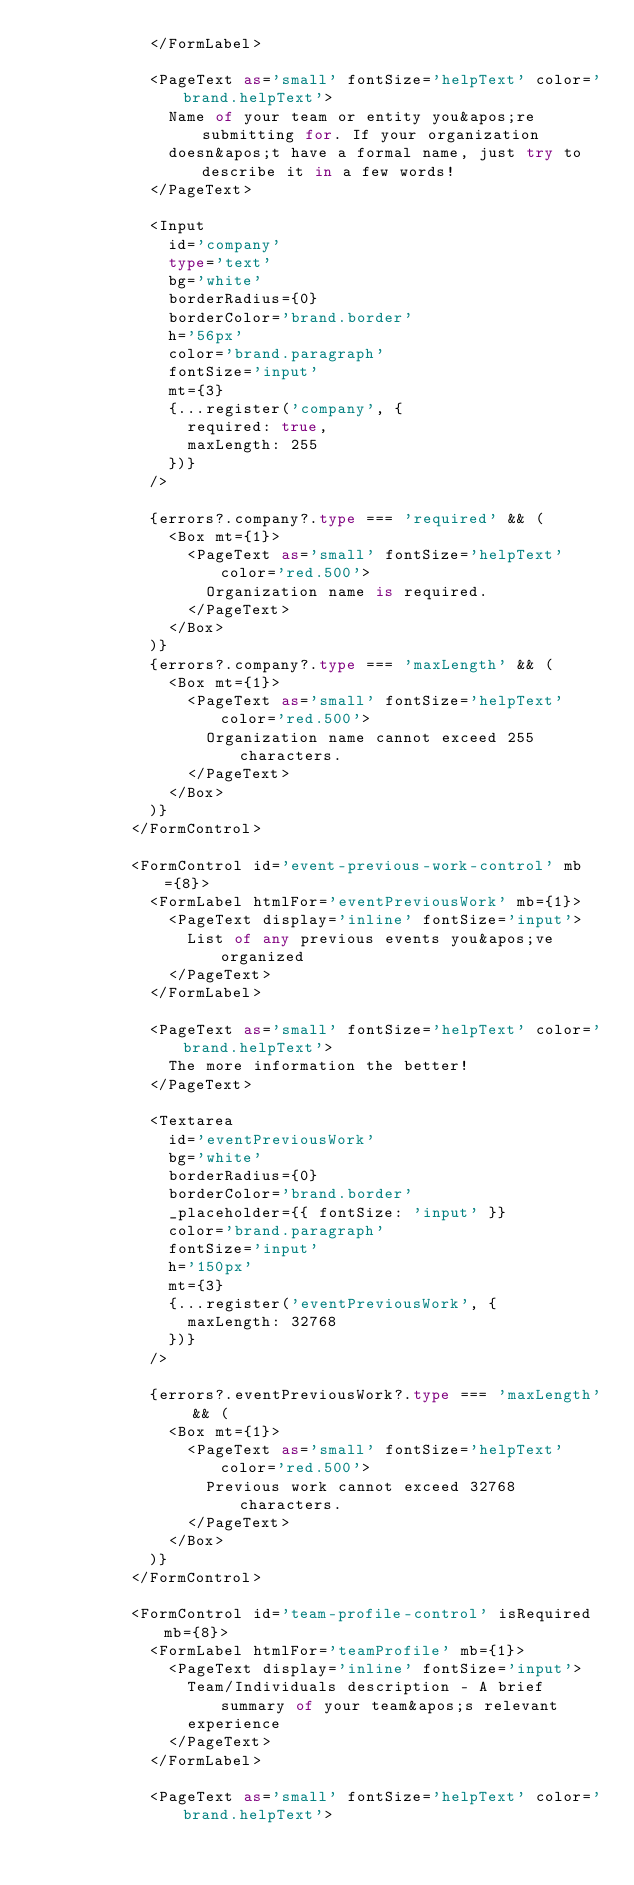Convert code to text. <code><loc_0><loc_0><loc_500><loc_500><_TypeScript_>            </FormLabel>

            <PageText as='small' fontSize='helpText' color='brand.helpText'>
              Name of your team or entity you&apos;re submitting for. If your organization
              doesn&apos;t have a formal name, just try to describe it in a few words!
            </PageText>

            <Input
              id='company'
              type='text'
              bg='white'
              borderRadius={0}
              borderColor='brand.border'
              h='56px'
              color='brand.paragraph'
              fontSize='input'
              mt={3}
              {...register('company', {
                required: true,
                maxLength: 255
              })}
            />

            {errors?.company?.type === 'required' && (
              <Box mt={1}>
                <PageText as='small' fontSize='helpText' color='red.500'>
                  Organization name is required.
                </PageText>
              </Box>
            )}
            {errors?.company?.type === 'maxLength' && (
              <Box mt={1}>
                <PageText as='small' fontSize='helpText' color='red.500'>
                  Organization name cannot exceed 255 characters.
                </PageText>
              </Box>
            )}
          </FormControl>

          <FormControl id='event-previous-work-control' mb={8}>
            <FormLabel htmlFor='eventPreviousWork' mb={1}>
              <PageText display='inline' fontSize='input'>
                List of any previous events you&apos;ve organized
              </PageText>
            </FormLabel>

            <PageText as='small' fontSize='helpText' color='brand.helpText'>
              The more information the better!
            </PageText>

            <Textarea
              id='eventPreviousWork'
              bg='white'
              borderRadius={0}
              borderColor='brand.border'
              _placeholder={{ fontSize: 'input' }}
              color='brand.paragraph'
              fontSize='input'
              h='150px'
              mt={3}
              {...register('eventPreviousWork', {
                maxLength: 32768
              })}
            />

            {errors?.eventPreviousWork?.type === 'maxLength' && (
              <Box mt={1}>
                <PageText as='small' fontSize='helpText' color='red.500'>
                  Previous work cannot exceed 32768 characters.
                </PageText>
              </Box>
            )}
          </FormControl>

          <FormControl id='team-profile-control' isRequired mb={8}>
            <FormLabel htmlFor='teamProfile' mb={1}>
              <PageText display='inline' fontSize='input'>
                Team/Individuals description - A brief summary of your team&apos;s relevant
                experience
              </PageText>
            </FormLabel>

            <PageText as='small' fontSize='helpText' color='brand.helpText'></code> 